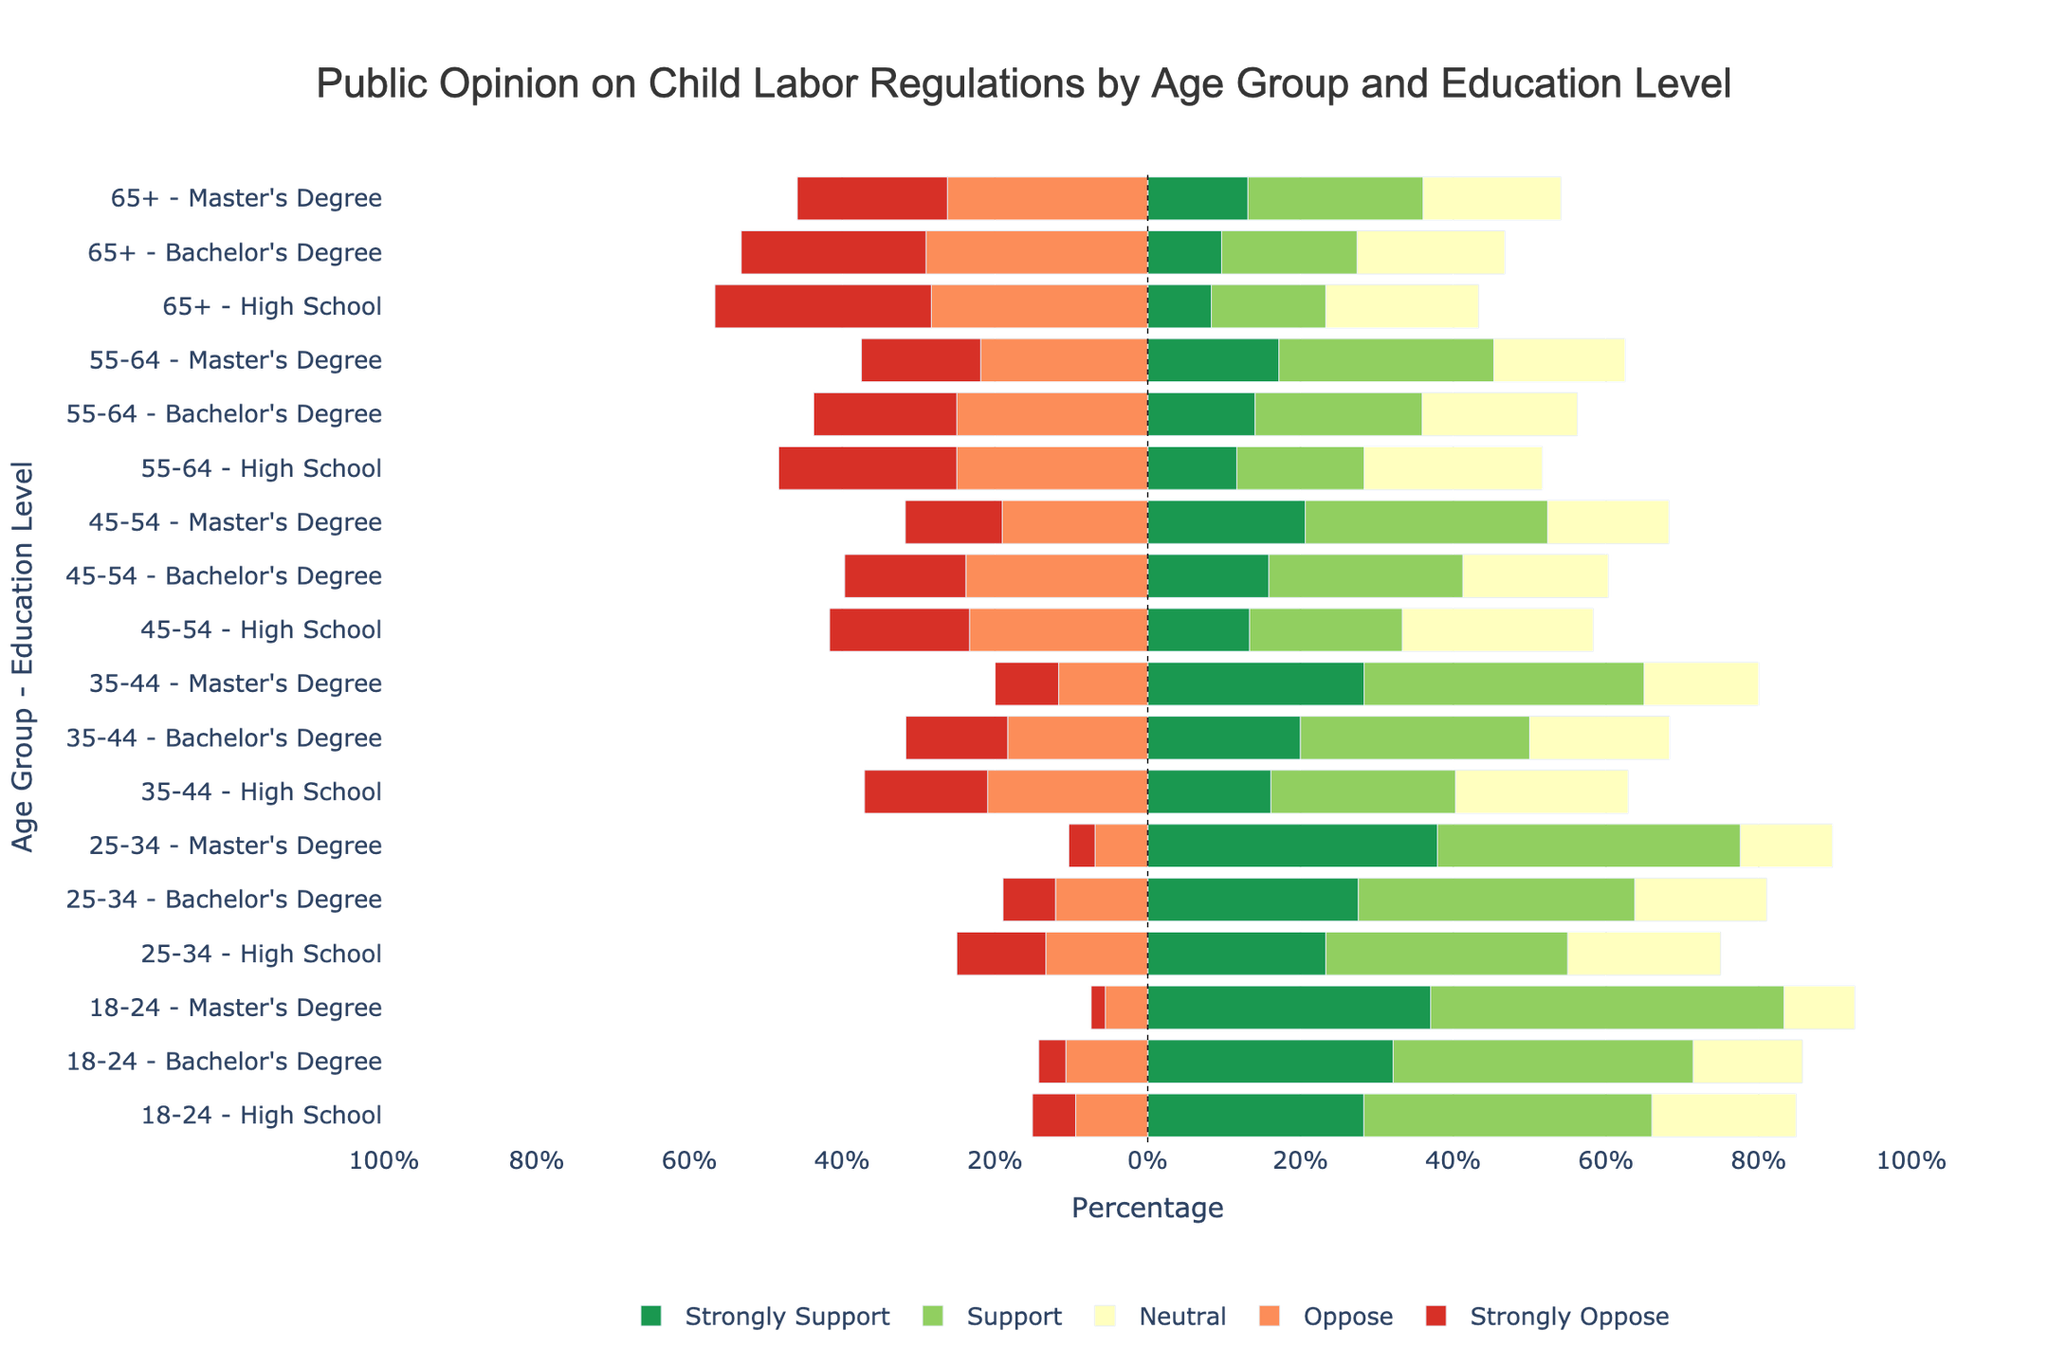Which age group with a bachelor's degree has the highest combined percentage of 'Strongly Support' and 'Support'? To determine this, sum up the 'Strongly Support' and 'Support' percentages for each age group with a bachelor's degree. 
18-24: 18% + 22% = 40%, 
25-34: 16% + 21% = 37%, 
35-44: 12% + 18% = 30%, 
45-54: 10% + 16% = 26%, 
55-64: 9% + 14% = 23%, 
65+: 6% + 11% = 17%. 
The highest combined percentage is 40% for the 18-24 age group.
Answer: 18-24 What is the difference in the percentage of 'Strongly Oppose' between the 35-44 and 55-64 age groups with a high school education? Look at the 'Strongly Oppose' percentages for the 35-44 and 55-64 age groups with a high school education. 
35-44: 10%, 
55-64: 14%. 
The difference is 14% - 10% = 4%.
Answer: 4% Which group has the highest percentage of 'Neutral' opinion? To find this, check the 'Neutral' percentage for each group across all age-groups and education levels. The highest value on the chart corresponds to the 45-54 age group with a high school education, which is 15%.
Answer: 45-54, High School How does the 'Oppose' percentage for the 25-34 age group with a master's degree compare to the 65+ age group with a bachelor's degree? Look at the 'Oppose' percentages for both groups:
25-34 with a master's degree: 4%, 
65+ with a bachelor's degree: 18%.
Comparing these values, 4% is less than 18%.
Answer: 25-34 group (less) Determine the average percentage of 'Support' across all age groups with a master's degree. Calculate the 'Support' percentages for each age group with a master's degree:
18-24: 25%, 
25-34: 23%, 
35-44: 22%, 
45-54: 20%, 
55-64: 18%, 
65+: 14%. 
Add these values: 25% + 23% + 22% + 20% + 18% + 14% = 122%.
Now divide by the number of groups (6). 122% / 6 = ~20.3%.
Answer: 20.3% Which age group with high school education has the smallest combined percentage of 'Oppose' and 'Strongly Oppose'? Sum up the 'Oppose' and 'Strongly Oppose' percentages for each age group with high school education:
18-24: 5% + 3% = 8%, 
25-34: 8% + 7% = 15%, 
35-44: 13% + 10% = 23%, 
45-54: 14% + 11% = 25%, 
55-64: 15% + 14% = 29%, 
65+: 17% + 17% = 34%.
The smallest percentage is 8% for the 18-24 age group.
Answer: 18-24 In the 55-64 age group, which education level has the highest 'Strongly Support' percentage? Compare the 'Strongly Support' percentages for all education levels within the 55-64 age group:
High School: 7%, 
Bachelor's Degree: 9%, 
Master's Degree: 11%. 
The highest is 11% for the master's degree.
Answer: Master's Degree How many age group and education level combinations have more than 10% 'Strongly Support'? Count all the groups where the 'Strongly Support' percentage is greater than 10%.
18-24: All (High School: 15%, Bachelor's Degree: 18%, Master's Degree: 20%), 
25-34: Only Master's Degree (22%), 
35-44: Only Master's Degree (17%), 
45-54: Only Master's Degree (13%), 
55-64: Only Master's Degree (11%), 
65+: None.
In total, there are 6 combinations.
Answer: 6 